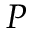<formula> <loc_0><loc_0><loc_500><loc_500>P</formula> 